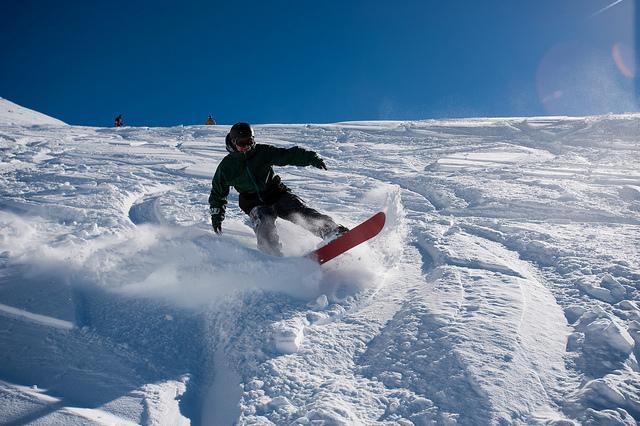How many cars are to the left of the carriage?
Give a very brief answer. 0. 